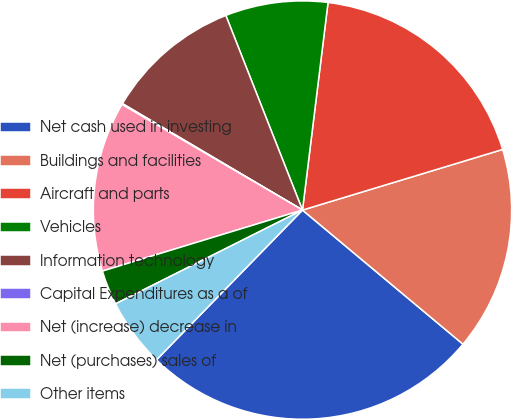Convert chart to OTSL. <chart><loc_0><loc_0><loc_500><loc_500><pie_chart><fcel>Net cash used in investing<fcel>Buildings and facilities<fcel>Aircraft and parts<fcel>Vehicles<fcel>Information technology<fcel>Capital Expenditures as a of<fcel>Net (increase) decrease in<fcel>Net (purchases) sales of<fcel>Other items<nl><fcel>26.22%<fcel>15.76%<fcel>18.37%<fcel>7.92%<fcel>10.53%<fcel>0.07%<fcel>13.14%<fcel>2.69%<fcel>5.3%<nl></chart> 